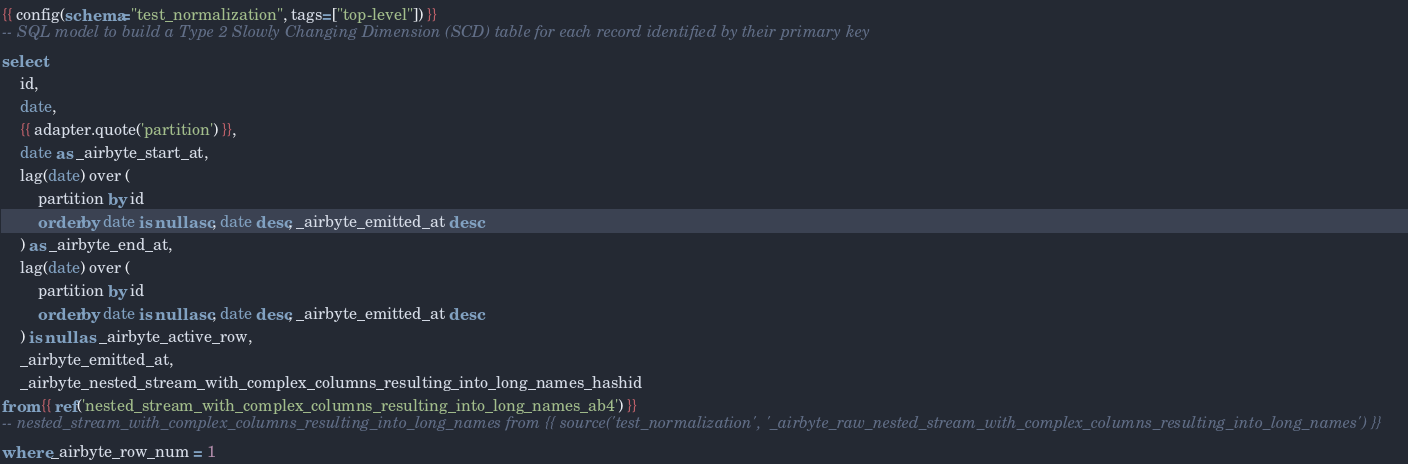Convert code to text. <code><loc_0><loc_0><loc_500><loc_500><_SQL_>{{ config(schema="test_normalization", tags=["top-level"]) }}
-- SQL model to build a Type 2 Slowly Changing Dimension (SCD) table for each record identified by their primary key
select
    id,
    date,
    {{ adapter.quote('partition') }},
    date as _airbyte_start_at,
    lag(date) over (
        partition by id
        order by date is null asc, date desc, _airbyte_emitted_at desc
    ) as _airbyte_end_at,
    lag(date) over (
        partition by id
        order by date is null asc, date desc, _airbyte_emitted_at desc
    ) is null as _airbyte_active_row,
    _airbyte_emitted_at,
    _airbyte_nested_stream_with_complex_columns_resulting_into_long_names_hashid
from {{ ref('nested_stream_with_complex_columns_resulting_into_long_names_ab4') }}
-- nested_stream_with_complex_columns_resulting_into_long_names from {{ source('test_normalization', '_airbyte_raw_nested_stream_with_complex_columns_resulting_into_long_names') }}
where _airbyte_row_num = 1

</code> 